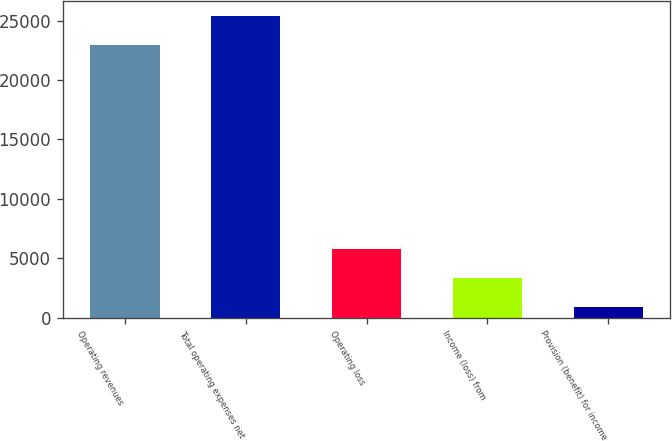Convert chart. <chart><loc_0><loc_0><loc_500><loc_500><bar_chart><fcel>Operating revenues<fcel>Total operating expenses net<fcel>Operating loss<fcel>Income (loss) from<fcel>Provision (benefit) for income<nl><fcel>22922<fcel>25389<fcel>5787.4<fcel>3337.2<fcel>887<nl></chart> 